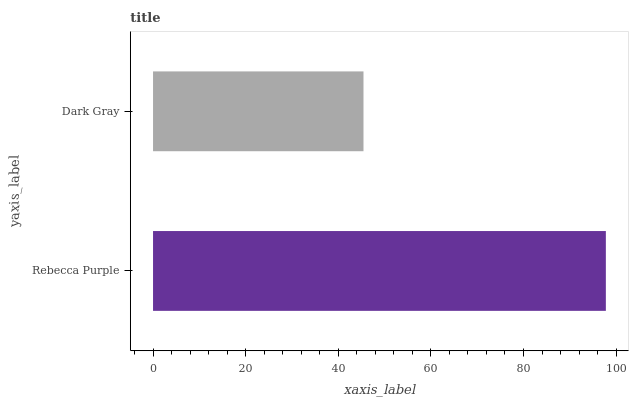Is Dark Gray the minimum?
Answer yes or no. Yes. Is Rebecca Purple the maximum?
Answer yes or no. Yes. Is Dark Gray the maximum?
Answer yes or no. No. Is Rebecca Purple greater than Dark Gray?
Answer yes or no. Yes. Is Dark Gray less than Rebecca Purple?
Answer yes or no. Yes. Is Dark Gray greater than Rebecca Purple?
Answer yes or no. No. Is Rebecca Purple less than Dark Gray?
Answer yes or no. No. Is Rebecca Purple the high median?
Answer yes or no. Yes. Is Dark Gray the low median?
Answer yes or no. Yes. Is Dark Gray the high median?
Answer yes or no. No. Is Rebecca Purple the low median?
Answer yes or no. No. 